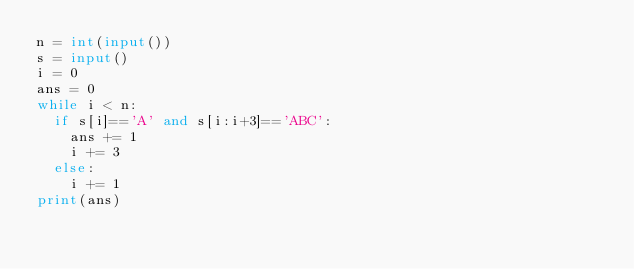Convert code to text. <code><loc_0><loc_0><loc_500><loc_500><_Python_>n = int(input())
s = input()
i = 0
ans = 0
while i < n:
  if s[i]=='A' and s[i:i+3]=='ABC':
    ans += 1
    i += 3
  else:
    i += 1
print(ans)</code> 